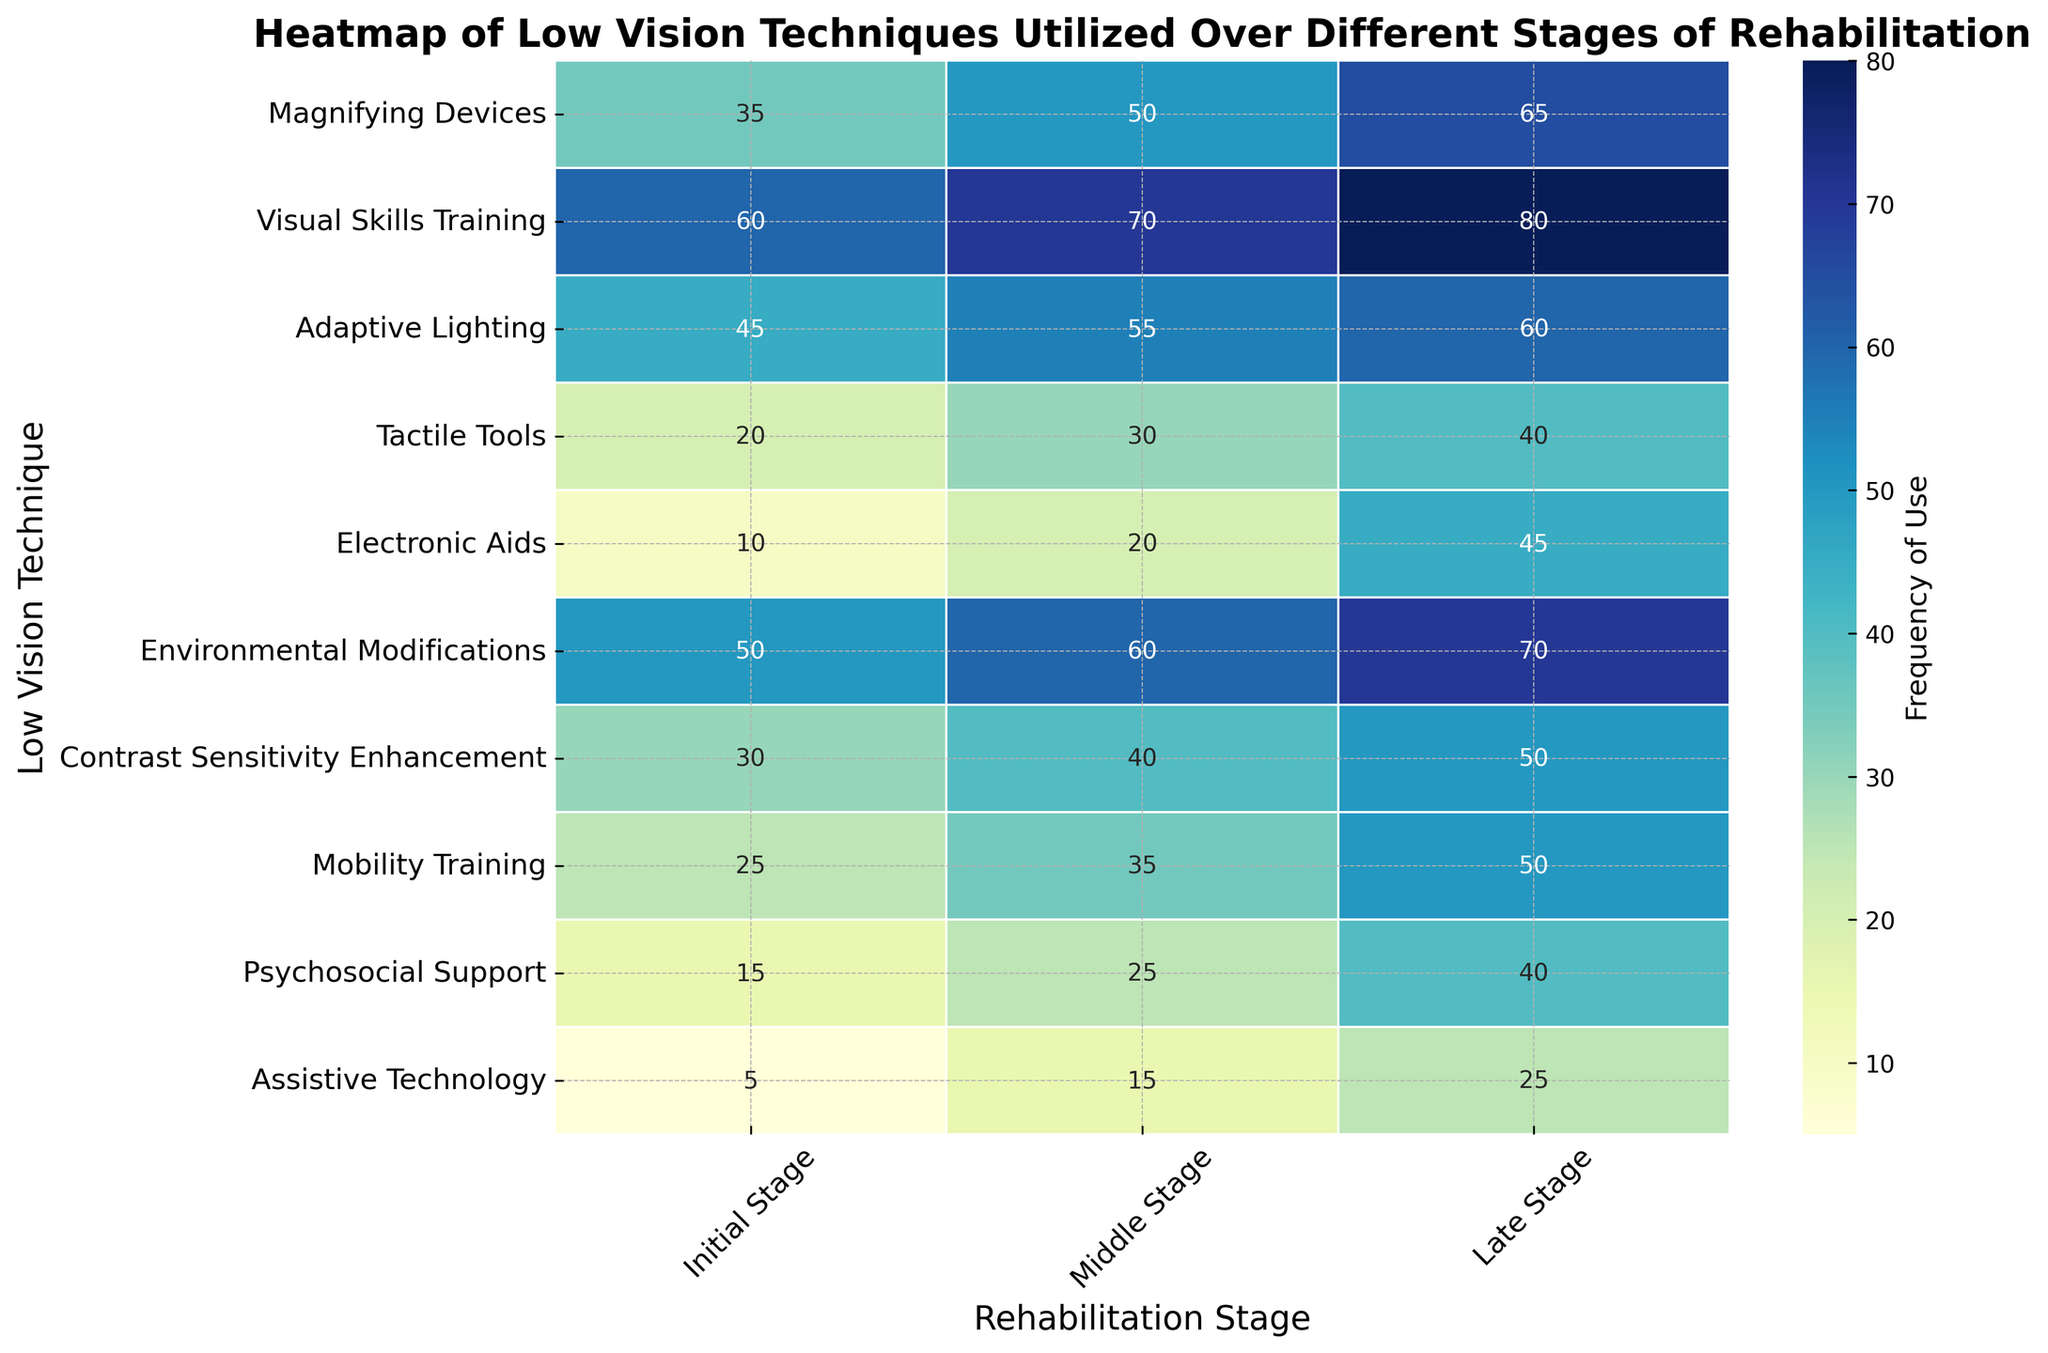What technique has the highest frequency in the Initial Stage? By looking at the heatmap's axis labeled 'Low Vision Technique', find the technique with the highest value in the column labeled 'Initial Stage'. The highest value is 60, associated with 'Visual Skills Training'.
Answer: Visual Skills Training Which stage has the highest frequency for 'Electronic Aids'? Locate the row corresponding to 'Electronic Aids' on the heatmap. Compare the values across the 'Initial Stage', 'Middle Stage', and 'Late Stage' columns. The highest value is 45 in the 'Late Stage'.
Answer: Late Stage What is the sum of the frequencies for 'Mobility Training' across all stages? Identify the row for 'Mobility Training' in the heatmap. Sum the values in the columns 'Initial Stage' (25), 'Middle Stage' (35), and 'Late Stage' (50). So, 25 + 35 + 50 = 110.
Answer: 110 Which technique shows the greatest increase in frequency from the Initial Stage to the Late Stage? Calculate the difference between the 'Late Stage' and 'Initial Stage' values for all techniques. Identify the technique with the largest difference. For 'Electronic Aids', the increase is 45 - 10 = 35, which is the highest.
Answer: Electronic Aids Compare the frequency of 'Tactile Tools' in the Middle Stage with 'Adaptive Lighting' in the Late Stage. Which is higher? Look at the heatmap values for 'Tactile Tools' in the 'Middle Stage' (30) and 'Adaptive Lighting' in the 'Late Stage' (60). The value 60 is higher than 30.
Answer: Adaptive Lighting in the Late Stage What is the average frequency of 'Visual Skills Training' across all stages? Sum the values for 'Visual Skills Training' in all stages (60 + 70 + 80) to get 210. Divide by the number of stages (3), which results in 210 / 3 = 70.
Answer: 70 Which technique has a consistent 10-unit increase from the Initial to Middle to Late Stage? Observe the values for each technique across the stages. 'Contrast Sensitivity Enhancement' changes from 30 (Initial) to 40 (Middle) to 50 (Late), demonstrating a consistent 10-unit increase.
Answer: Contrast Sensitivity Enhancement What color tone dominates the heatmap for the 'Assistive Technology' row? The tone for 'Assistive Technology' in all stages shows lighter shading compared to others. This indicates lower frequency usage, represented by lighter blue tones.
Answer: Light blue Is 'Adaptive Lighting' used more frequently in the Initial Stage or 'Magnifying Devices' in the Late Stage? Check the heatmap values: 'Adaptive Lighting' in the Initial Stage is 45, and 'Magnifying Devices' in the Late Stage is 65. Comparatively, 65 is higher than 45.
Answer: Magnifying Devices in the Late Stage Which technique has the lowest frequency in the Middle Stage? Identify the column for the 'Middle Stage' on the heatmap and locate the lowest value. 'Assistive Technology' has the lowest frequency at 15.
Answer: Assistive Technology 